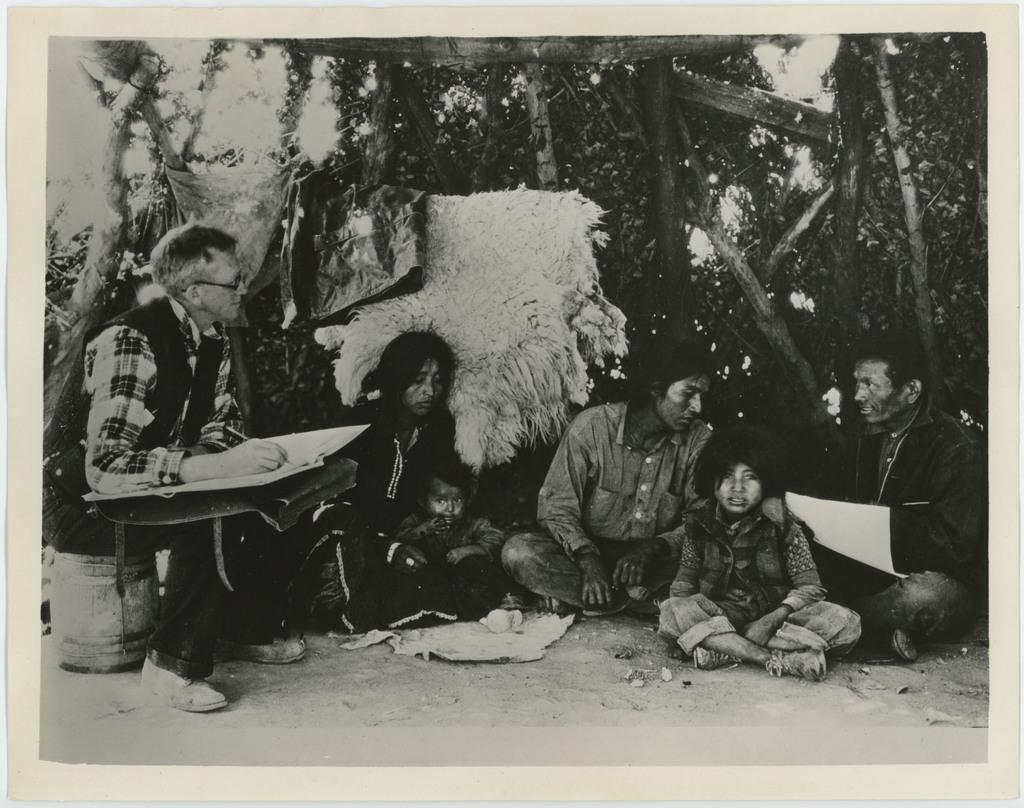What are the people in the image doing? The people in the image are sitting. What are the people wearing? The people are wearing clothes. What can be seen besides the people in the image? There is a book, an object, spectacles, a wooden fence, and leaves visible in the image. What type of friction can be seen between the people and the wooden fence in the image? There is no friction visible between the people and the wooden fence in the image. How many birds are perched on the wooden fence in the image? There are no birds present in the image. 